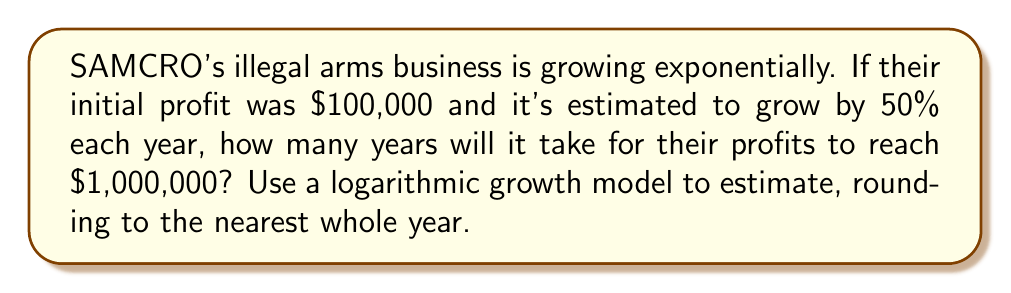Teach me how to tackle this problem. Let's approach this step-by-step using a logarithmic growth model:

1) The general form of exponential growth is:
   $$ A = P(1 + r)^t $$
   Where:
   $A$ is the final amount
   $P$ is the initial principal
   $r$ is the growth rate
   $t$ is the time in years

2) We know:
   $P = 100,000$
   $r = 0.50$ (50% growth rate)
   $A = 1,000,000$

3) Plugging these into our equation:
   $$ 1,000,000 = 100,000(1 + 0.50)^t $$

4) Simplify:
   $$ 10 = 1.5^t $$

5) To solve for $t$, we need to take the logarithm of both sides. We can use any base, but natural log (ln) is common:
   $$ \ln(10) = \ln(1.5^t) $$

6) Using the logarithm property $\ln(a^b) = b\ln(a)$:
   $$ \ln(10) = t\ln(1.5) $$

7) Solve for $t$:
   $$ t = \frac{\ln(10)}{\ln(1.5)} $$

8) Calculate:
   $$ t \approx 4.19 $$

9) Rounding to the nearest whole year:
   $$ t \approx 4 \text{ years} $$
Answer: 4 years 